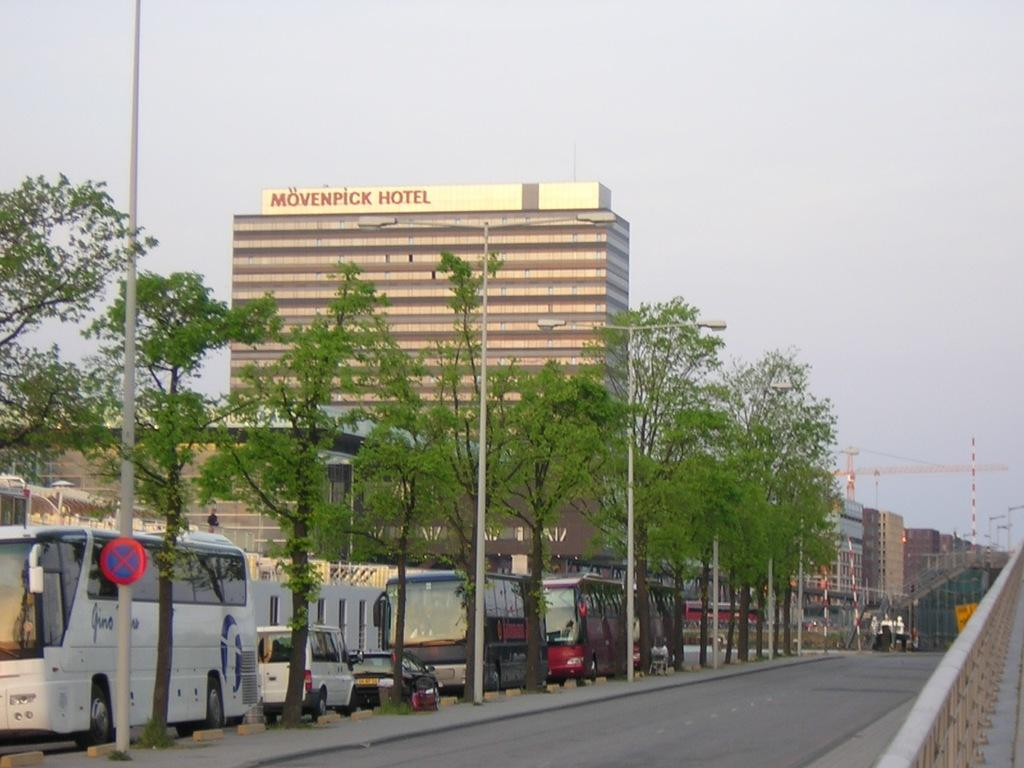What can be seen on the road in the image? There are vehicles on the road in the image. What objects are present in the image that support or hold something? There are poles in the image. What can be seen illuminating the area in the image? There are lights in the image. What flat, rectangular objects can be seen in the image? There are boards in the image. What type of vegetation is visible in the image? There are trees in the image. What type of structures are visible in the image? There are buildings in the image. What is visible in the background of the image? The sky is visible in the background of the image. What type of story is being told by the silver existence in the image? There is no reference to a story, silver, or existence in the image; it features vehicles on the road, poles, lights, boards, trees, buildings, and the sky. 